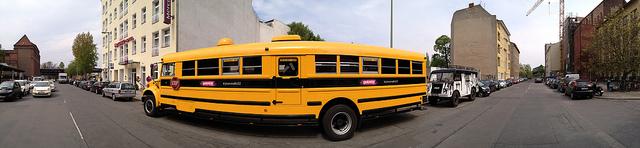What kind of bus is this?
Be succinct. School. Do you see any houses?
Write a very short answer. No. How many windows are on the bus?
Quick response, please. 12. 